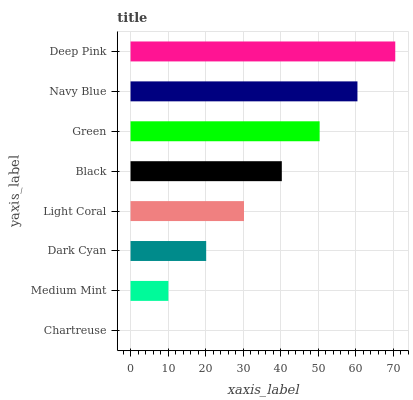Is Chartreuse the minimum?
Answer yes or no. Yes. Is Deep Pink the maximum?
Answer yes or no. Yes. Is Medium Mint the minimum?
Answer yes or no. No. Is Medium Mint the maximum?
Answer yes or no. No. Is Medium Mint greater than Chartreuse?
Answer yes or no. Yes. Is Chartreuse less than Medium Mint?
Answer yes or no. Yes. Is Chartreuse greater than Medium Mint?
Answer yes or no. No. Is Medium Mint less than Chartreuse?
Answer yes or no. No. Is Black the high median?
Answer yes or no. Yes. Is Light Coral the low median?
Answer yes or no. Yes. Is Light Coral the high median?
Answer yes or no. No. Is Black the low median?
Answer yes or no. No. 